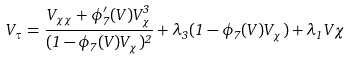Convert formula to latex. <formula><loc_0><loc_0><loc_500><loc_500>V _ { \tau } = \frac { V _ { \chi \chi } + \phi _ { 7 } ^ { \prime } ( V ) V _ { \chi } ^ { 3 } } { ( 1 - \phi _ { 7 } ( V ) V _ { \chi } ) ^ { 2 } } + \lambda _ { 3 } ( 1 - \phi _ { 7 } ( V ) V _ { \chi } ) + \lambda _ { 1 } V \chi</formula> 